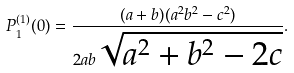Convert formula to latex. <formula><loc_0><loc_0><loc_500><loc_500>P ^ { ( 1 ) } _ { 1 } ( 0 ) = \frac { ( a + b ) ( a ^ { 2 } b ^ { 2 } - c ^ { 2 } ) } { 2 a b \sqrt { a ^ { 2 } + b ^ { 2 } - 2 c } } .</formula> 